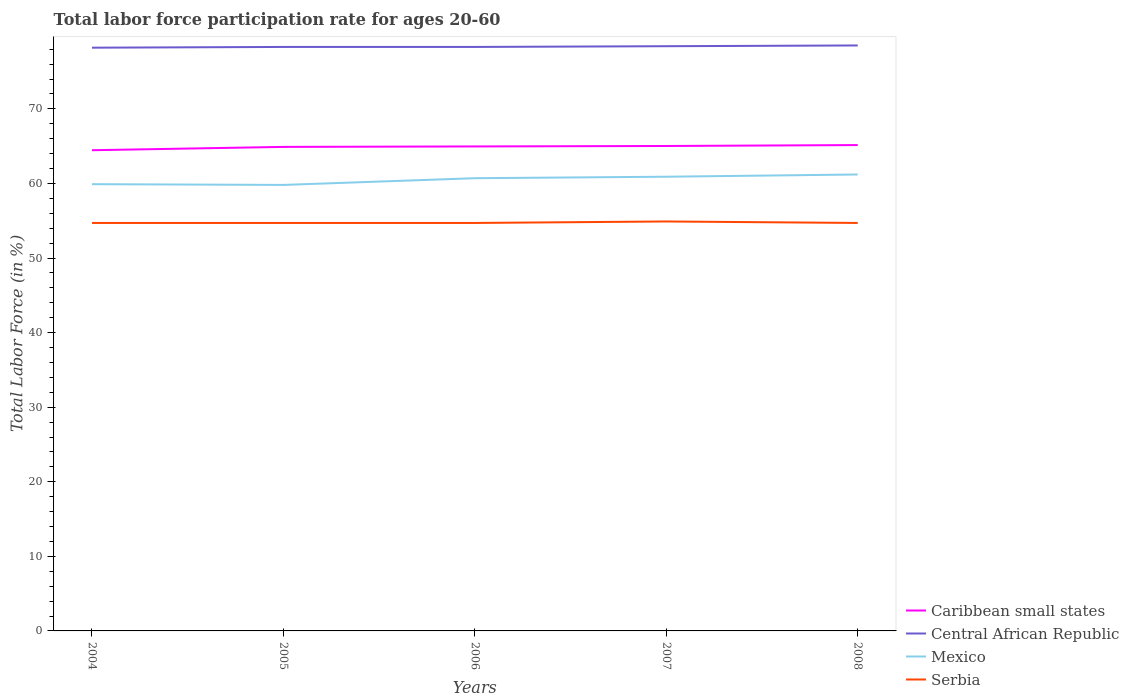Across all years, what is the maximum labor force participation rate in Caribbean small states?
Provide a short and direct response. 64.45. What is the total labor force participation rate in Mexico in the graph?
Your response must be concise. 0.1. What is the difference between the highest and the second highest labor force participation rate in Mexico?
Your response must be concise. 1.4. What is the difference between the highest and the lowest labor force participation rate in Caribbean small states?
Offer a terse response. 4. How many years are there in the graph?
Offer a terse response. 5. What is the difference between two consecutive major ticks on the Y-axis?
Your answer should be compact. 10. Does the graph contain any zero values?
Keep it short and to the point. No. How many legend labels are there?
Offer a terse response. 4. What is the title of the graph?
Ensure brevity in your answer.  Total labor force participation rate for ages 20-60. What is the label or title of the X-axis?
Make the answer very short. Years. What is the Total Labor Force (in %) in Caribbean small states in 2004?
Give a very brief answer. 64.45. What is the Total Labor Force (in %) of Central African Republic in 2004?
Make the answer very short. 78.2. What is the Total Labor Force (in %) in Mexico in 2004?
Provide a succinct answer. 59.9. What is the Total Labor Force (in %) of Serbia in 2004?
Your answer should be compact. 54.7. What is the Total Labor Force (in %) in Caribbean small states in 2005?
Provide a short and direct response. 64.9. What is the Total Labor Force (in %) in Central African Republic in 2005?
Make the answer very short. 78.3. What is the Total Labor Force (in %) of Mexico in 2005?
Offer a very short reply. 59.8. What is the Total Labor Force (in %) of Serbia in 2005?
Offer a terse response. 54.7. What is the Total Labor Force (in %) of Caribbean small states in 2006?
Your answer should be compact. 64.96. What is the Total Labor Force (in %) of Central African Republic in 2006?
Keep it short and to the point. 78.3. What is the Total Labor Force (in %) of Mexico in 2006?
Ensure brevity in your answer.  60.7. What is the Total Labor Force (in %) of Serbia in 2006?
Your answer should be very brief. 54.7. What is the Total Labor Force (in %) of Caribbean small states in 2007?
Keep it short and to the point. 65.02. What is the Total Labor Force (in %) in Central African Republic in 2007?
Offer a terse response. 78.4. What is the Total Labor Force (in %) of Mexico in 2007?
Keep it short and to the point. 60.9. What is the Total Labor Force (in %) in Serbia in 2007?
Offer a terse response. 54.9. What is the Total Labor Force (in %) of Caribbean small states in 2008?
Provide a succinct answer. 65.14. What is the Total Labor Force (in %) in Central African Republic in 2008?
Provide a succinct answer. 78.5. What is the Total Labor Force (in %) of Mexico in 2008?
Make the answer very short. 61.2. What is the Total Labor Force (in %) in Serbia in 2008?
Make the answer very short. 54.7. Across all years, what is the maximum Total Labor Force (in %) of Caribbean small states?
Give a very brief answer. 65.14. Across all years, what is the maximum Total Labor Force (in %) of Central African Republic?
Give a very brief answer. 78.5. Across all years, what is the maximum Total Labor Force (in %) in Mexico?
Provide a succinct answer. 61.2. Across all years, what is the maximum Total Labor Force (in %) of Serbia?
Make the answer very short. 54.9. Across all years, what is the minimum Total Labor Force (in %) of Caribbean small states?
Your answer should be very brief. 64.45. Across all years, what is the minimum Total Labor Force (in %) of Central African Republic?
Make the answer very short. 78.2. Across all years, what is the minimum Total Labor Force (in %) in Mexico?
Your answer should be very brief. 59.8. Across all years, what is the minimum Total Labor Force (in %) in Serbia?
Offer a very short reply. 54.7. What is the total Total Labor Force (in %) of Caribbean small states in the graph?
Your answer should be compact. 324.48. What is the total Total Labor Force (in %) of Central African Republic in the graph?
Your response must be concise. 391.7. What is the total Total Labor Force (in %) of Mexico in the graph?
Your response must be concise. 302.5. What is the total Total Labor Force (in %) in Serbia in the graph?
Provide a succinct answer. 273.7. What is the difference between the Total Labor Force (in %) of Caribbean small states in 2004 and that in 2005?
Ensure brevity in your answer.  -0.45. What is the difference between the Total Labor Force (in %) in Central African Republic in 2004 and that in 2005?
Your answer should be very brief. -0.1. What is the difference between the Total Labor Force (in %) of Mexico in 2004 and that in 2005?
Your response must be concise. 0.1. What is the difference between the Total Labor Force (in %) of Serbia in 2004 and that in 2005?
Ensure brevity in your answer.  0. What is the difference between the Total Labor Force (in %) in Caribbean small states in 2004 and that in 2006?
Offer a terse response. -0.51. What is the difference between the Total Labor Force (in %) of Serbia in 2004 and that in 2006?
Your answer should be compact. 0. What is the difference between the Total Labor Force (in %) of Caribbean small states in 2004 and that in 2007?
Your response must be concise. -0.57. What is the difference between the Total Labor Force (in %) of Caribbean small states in 2004 and that in 2008?
Provide a succinct answer. -0.69. What is the difference between the Total Labor Force (in %) in Central African Republic in 2004 and that in 2008?
Provide a succinct answer. -0.3. What is the difference between the Total Labor Force (in %) in Caribbean small states in 2005 and that in 2006?
Your answer should be very brief. -0.06. What is the difference between the Total Labor Force (in %) of Mexico in 2005 and that in 2006?
Offer a terse response. -0.9. What is the difference between the Total Labor Force (in %) of Serbia in 2005 and that in 2006?
Your response must be concise. 0. What is the difference between the Total Labor Force (in %) in Caribbean small states in 2005 and that in 2007?
Keep it short and to the point. -0.12. What is the difference between the Total Labor Force (in %) of Caribbean small states in 2005 and that in 2008?
Offer a terse response. -0.25. What is the difference between the Total Labor Force (in %) of Mexico in 2005 and that in 2008?
Provide a short and direct response. -1.4. What is the difference between the Total Labor Force (in %) in Caribbean small states in 2006 and that in 2007?
Your response must be concise. -0.06. What is the difference between the Total Labor Force (in %) in Caribbean small states in 2006 and that in 2008?
Ensure brevity in your answer.  -0.18. What is the difference between the Total Labor Force (in %) in Central African Republic in 2006 and that in 2008?
Make the answer very short. -0.2. What is the difference between the Total Labor Force (in %) in Caribbean small states in 2007 and that in 2008?
Your response must be concise. -0.12. What is the difference between the Total Labor Force (in %) in Central African Republic in 2007 and that in 2008?
Your response must be concise. -0.1. What is the difference between the Total Labor Force (in %) of Mexico in 2007 and that in 2008?
Make the answer very short. -0.3. What is the difference between the Total Labor Force (in %) of Caribbean small states in 2004 and the Total Labor Force (in %) of Central African Republic in 2005?
Offer a very short reply. -13.85. What is the difference between the Total Labor Force (in %) of Caribbean small states in 2004 and the Total Labor Force (in %) of Mexico in 2005?
Your answer should be compact. 4.65. What is the difference between the Total Labor Force (in %) of Caribbean small states in 2004 and the Total Labor Force (in %) of Serbia in 2005?
Offer a terse response. 9.75. What is the difference between the Total Labor Force (in %) of Central African Republic in 2004 and the Total Labor Force (in %) of Mexico in 2005?
Your response must be concise. 18.4. What is the difference between the Total Labor Force (in %) of Central African Republic in 2004 and the Total Labor Force (in %) of Serbia in 2005?
Your answer should be compact. 23.5. What is the difference between the Total Labor Force (in %) of Caribbean small states in 2004 and the Total Labor Force (in %) of Central African Republic in 2006?
Ensure brevity in your answer.  -13.85. What is the difference between the Total Labor Force (in %) in Caribbean small states in 2004 and the Total Labor Force (in %) in Mexico in 2006?
Give a very brief answer. 3.75. What is the difference between the Total Labor Force (in %) in Caribbean small states in 2004 and the Total Labor Force (in %) in Serbia in 2006?
Your response must be concise. 9.75. What is the difference between the Total Labor Force (in %) of Central African Republic in 2004 and the Total Labor Force (in %) of Mexico in 2006?
Give a very brief answer. 17.5. What is the difference between the Total Labor Force (in %) of Mexico in 2004 and the Total Labor Force (in %) of Serbia in 2006?
Give a very brief answer. 5.2. What is the difference between the Total Labor Force (in %) in Caribbean small states in 2004 and the Total Labor Force (in %) in Central African Republic in 2007?
Give a very brief answer. -13.95. What is the difference between the Total Labor Force (in %) of Caribbean small states in 2004 and the Total Labor Force (in %) of Mexico in 2007?
Give a very brief answer. 3.55. What is the difference between the Total Labor Force (in %) in Caribbean small states in 2004 and the Total Labor Force (in %) in Serbia in 2007?
Offer a terse response. 9.55. What is the difference between the Total Labor Force (in %) in Central African Republic in 2004 and the Total Labor Force (in %) in Serbia in 2007?
Your response must be concise. 23.3. What is the difference between the Total Labor Force (in %) in Mexico in 2004 and the Total Labor Force (in %) in Serbia in 2007?
Offer a terse response. 5. What is the difference between the Total Labor Force (in %) in Caribbean small states in 2004 and the Total Labor Force (in %) in Central African Republic in 2008?
Your answer should be very brief. -14.05. What is the difference between the Total Labor Force (in %) in Caribbean small states in 2004 and the Total Labor Force (in %) in Mexico in 2008?
Make the answer very short. 3.25. What is the difference between the Total Labor Force (in %) in Caribbean small states in 2004 and the Total Labor Force (in %) in Serbia in 2008?
Your answer should be very brief. 9.75. What is the difference between the Total Labor Force (in %) of Caribbean small states in 2005 and the Total Labor Force (in %) of Central African Republic in 2006?
Your response must be concise. -13.4. What is the difference between the Total Labor Force (in %) in Caribbean small states in 2005 and the Total Labor Force (in %) in Mexico in 2006?
Provide a short and direct response. 4.2. What is the difference between the Total Labor Force (in %) of Caribbean small states in 2005 and the Total Labor Force (in %) of Serbia in 2006?
Provide a succinct answer. 10.2. What is the difference between the Total Labor Force (in %) of Central African Republic in 2005 and the Total Labor Force (in %) of Serbia in 2006?
Provide a succinct answer. 23.6. What is the difference between the Total Labor Force (in %) of Caribbean small states in 2005 and the Total Labor Force (in %) of Central African Republic in 2007?
Make the answer very short. -13.5. What is the difference between the Total Labor Force (in %) in Caribbean small states in 2005 and the Total Labor Force (in %) in Mexico in 2007?
Make the answer very short. 4. What is the difference between the Total Labor Force (in %) in Caribbean small states in 2005 and the Total Labor Force (in %) in Serbia in 2007?
Your answer should be compact. 10. What is the difference between the Total Labor Force (in %) in Central African Republic in 2005 and the Total Labor Force (in %) in Mexico in 2007?
Offer a very short reply. 17.4. What is the difference between the Total Labor Force (in %) in Central African Republic in 2005 and the Total Labor Force (in %) in Serbia in 2007?
Keep it short and to the point. 23.4. What is the difference between the Total Labor Force (in %) in Caribbean small states in 2005 and the Total Labor Force (in %) in Central African Republic in 2008?
Provide a short and direct response. -13.6. What is the difference between the Total Labor Force (in %) in Caribbean small states in 2005 and the Total Labor Force (in %) in Mexico in 2008?
Make the answer very short. 3.7. What is the difference between the Total Labor Force (in %) of Caribbean small states in 2005 and the Total Labor Force (in %) of Serbia in 2008?
Provide a succinct answer. 10.2. What is the difference between the Total Labor Force (in %) of Central African Republic in 2005 and the Total Labor Force (in %) of Serbia in 2008?
Ensure brevity in your answer.  23.6. What is the difference between the Total Labor Force (in %) of Caribbean small states in 2006 and the Total Labor Force (in %) of Central African Republic in 2007?
Your answer should be compact. -13.44. What is the difference between the Total Labor Force (in %) in Caribbean small states in 2006 and the Total Labor Force (in %) in Mexico in 2007?
Provide a succinct answer. 4.06. What is the difference between the Total Labor Force (in %) of Caribbean small states in 2006 and the Total Labor Force (in %) of Serbia in 2007?
Your response must be concise. 10.06. What is the difference between the Total Labor Force (in %) in Central African Republic in 2006 and the Total Labor Force (in %) in Mexico in 2007?
Offer a very short reply. 17.4. What is the difference between the Total Labor Force (in %) in Central African Republic in 2006 and the Total Labor Force (in %) in Serbia in 2007?
Give a very brief answer. 23.4. What is the difference between the Total Labor Force (in %) in Caribbean small states in 2006 and the Total Labor Force (in %) in Central African Republic in 2008?
Provide a short and direct response. -13.54. What is the difference between the Total Labor Force (in %) of Caribbean small states in 2006 and the Total Labor Force (in %) of Mexico in 2008?
Your response must be concise. 3.76. What is the difference between the Total Labor Force (in %) of Caribbean small states in 2006 and the Total Labor Force (in %) of Serbia in 2008?
Your response must be concise. 10.26. What is the difference between the Total Labor Force (in %) in Central African Republic in 2006 and the Total Labor Force (in %) in Mexico in 2008?
Keep it short and to the point. 17.1. What is the difference between the Total Labor Force (in %) in Central African Republic in 2006 and the Total Labor Force (in %) in Serbia in 2008?
Your answer should be compact. 23.6. What is the difference between the Total Labor Force (in %) of Caribbean small states in 2007 and the Total Labor Force (in %) of Central African Republic in 2008?
Your answer should be very brief. -13.48. What is the difference between the Total Labor Force (in %) of Caribbean small states in 2007 and the Total Labor Force (in %) of Mexico in 2008?
Give a very brief answer. 3.82. What is the difference between the Total Labor Force (in %) in Caribbean small states in 2007 and the Total Labor Force (in %) in Serbia in 2008?
Ensure brevity in your answer.  10.32. What is the difference between the Total Labor Force (in %) in Central African Republic in 2007 and the Total Labor Force (in %) in Serbia in 2008?
Give a very brief answer. 23.7. What is the difference between the Total Labor Force (in %) in Mexico in 2007 and the Total Labor Force (in %) in Serbia in 2008?
Provide a succinct answer. 6.2. What is the average Total Labor Force (in %) in Caribbean small states per year?
Offer a terse response. 64.89. What is the average Total Labor Force (in %) of Central African Republic per year?
Keep it short and to the point. 78.34. What is the average Total Labor Force (in %) in Mexico per year?
Make the answer very short. 60.5. What is the average Total Labor Force (in %) of Serbia per year?
Provide a short and direct response. 54.74. In the year 2004, what is the difference between the Total Labor Force (in %) of Caribbean small states and Total Labor Force (in %) of Central African Republic?
Your answer should be very brief. -13.75. In the year 2004, what is the difference between the Total Labor Force (in %) in Caribbean small states and Total Labor Force (in %) in Mexico?
Your response must be concise. 4.55. In the year 2004, what is the difference between the Total Labor Force (in %) in Caribbean small states and Total Labor Force (in %) in Serbia?
Make the answer very short. 9.75. In the year 2004, what is the difference between the Total Labor Force (in %) in Mexico and Total Labor Force (in %) in Serbia?
Your answer should be compact. 5.2. In the year 2005, what is the difference between the Total Labor Force (in %) in Caribbean small states and Total Labor Force (in %) in Central African Republic?
Your answer should be compact. -13.4. In the year 2005, what is the difference between the Total Labor Force (in %) of Caribbean small states and Total Labor Force (in %) of Mexico?
Offer a terse response. 5.1. In the year 2005, what is the difference between the Total Labor Force (in %) of Caribbean small states and Total Labor Force (in %) of Serbia?
Offer a terse response. 10.2. In the year 2005, what is the difference between the Total Labor Force (in %) of Central African Republic and Total Labor Force (in %) of Serbia?
Make the answer very short. 23.6. In the year 2005, what is the difference between the Total Labor Force (in %) of Mexico and Total Labor Force (in %) of Serbia?
Provide a succinct answer. 5.1. In the year 2006, what is the difference between the Total Labor Force (in %) of Caribbean small states and Total Labor Force (in %) of Central African Republic?
Make the answer very short. -13.34. In the year 2006, what is the difference between the Total Labor Force (in %) in Caribbean small states and Total Labor Force (in %) in Mexico?
Your answer should be compact. 4.26. In the year 2006, what is the difference between the Total Labor Force (in %) of Caribbean small states and Total Labor Force (in %) of Serbia?
Your response must be concise. 10.26. In the year 2006, what is the difference between the Total Labor Force (in %) in Central African Republic and Total Labor Force (in %) in Mexico?
Your response must be concise. 17.6. In the year 2006, what is the difference between the Total Labor Force (in %) in Central African Republic and Total Labor Force (in %) in Serbia?
Your response must be concise. 23.6. In the year 2006, what is the difference between the Total Labor Force (in %) in Mexico and Total Labor Force (in %) in Serbia?
Keep it short and to the point. 6. In the year 2007, what is the difference between the Total Labor Force (in %) of Caribbean small states and Total Labor Force (in %) of Central African Republic?
Your response must be concise. -13.38. In the year 2007, what is the difference between the Total Labor Force (in %) of Caribbean small states and Total Labor Force (in %) of Mexico?
Your answer should be very brief. 4.12. In the year 2007, what is the difference between the Total Labor Force (in %) of Caribbean small states and Total Labor Force (in %) of Serbia?
Ensure brevity in your answer.  10.12. In the year 2007, what is the difference between the Total Labor Force (in %) of Central African Republic and Total Labor Force (in %) of Serbia?
Ensure brevity in your answer.  23.5. In the year 2008, what is the difference between the Total Labor Force (in %) of Caribbean small states and Total Labor Force (in %) of Central African Republic?
Offer a terse response. -13.36. In the year 2008, what is the difference between the Total Labor Force (in %) of Caribbean small states and Total Labor Force (in %) of Mexico?
Make the answer very short. 3.94. In the year 2008, what is the difference between the Total Labor Force (in %) in Caribbean small states and Total Labor Force (in %) in Serbia?
Your answer should be very brief. 10.44. In the year 2008, what is the difference between the Total Labor Force (in %) of Central African Republic and Total Labor Force (in %) of Mexico?
Offer a terse response. 17.3. In the year 2008, what is the difference between the Total Labor Force (in %) in Central African Republic and Total Labor Force (in %) in Serbia?
Your response must be concise. 23.8. What is the ratio of the Total Labor Force (in %) in Serbia in 2004 to that in 2006?
Make the answer very short. 1. What is the ratio of the Total Labor Force (in %) in Central African Republic in 2004 to that in 2007?
Offer a very short reply. 1. What is the ratio of the Total Labor Force (in %) of Mexico in 2004 to that in 2007?
Give a very brief answer. 0.98. What is the ratio of the Total Labor Force (in %) of Serbia in 2004 to that in 2007?
Your response must be concise. 1. What is the ratio of the Total Labor Force (in %) in Caribbean small states in 2004 to that in 2008?
Make the answer very short. 0.99. What is the ratio of the Total Labor Force (in %) in Central African Republic in 2004 to that in 2008?
Provide a short and direct response. 1. What is the ratio of the Total Labor Force (in %) of Mexico in 2004 to that in 2008?
Provide a succinct answer. 0.98. What is the ratio of the Total Labor Force (in %) in Caribbean small states in 2005 to that in 2006?
Give a very brief answer. 1. What is the ratio of the Total Labor Force (in %) of Central African Republic in 2005 to that in 2006?
Offer a very short reply. 1. What is the ratio of the Total Labor Force (in %) of Mexico in 2005 to that in 2006?
Give a very brief answer. 0.99. What is the ratio of the Total Labor Force (in %) in Serbia in 2005 to that in 2006?
Ensure brevity in your answer.  1. What is the ratio of the Total Labor Force (in %) in Central African Republic in 2005 to that in 2007?
Keep it short and to the point. 1. What is the ratio of the Total Labor Force (in %) of Mexico in 2005 to that in 2007?
Provide a succinct answer. 0.98. What is the ratio of the Total Labor Force (in %) of Caribbean small states in 2005 to that in 2008?
Your answer should be very brief. 1. What is the ratio of the Total Labor Force (in %) of Mexico in 2005 to that in 2008?
Your answer should be compact. 0.98. What is the ratio of the Total Labor Force (in %) in Caribbean small states in 2006 to that in 2007?
Your answer should be compact. 1. What is the ratio of the Total Labor Force (in %) in Serbia in 2006 to that in 2007?
Offer a very short reply. 1. What is the ratio of the Total Labor Force (in %) of Serbia in 2006 to that in 2008?
Your response must be concise. 1. What is the ratio of the Total Labor Force (in %) of Central African Republic in 2007 to that in 2008?
Your answer should be very brief. 1. What is the difference between the highest and the second highest Total Labor Force (in %) in Caribbean small states?
Provide a short and direct response. 0.12. What is the difference between the highest and the second highest Total Labor Force (in %) in Central African Republic?
Make the answer very short. 0.1. What is the difference between the highest and the second highest Total Labor Force (in %) in Mexico?
Make the answer very short. 0.3. What is the difference between the highest and the lowest Total Labor Force (in %) in Caribbean small states?
Ensure brevity in your answer.  0.69. What is the difference between the highest and the lowest Total Labor Force (in %) of Central African Republic?
Provide a succinct answer. 0.3. What is the difference between the highest and the lowest Total Labor Force (in %) in Mexico?
Offer a terse response. 1.4. What is the difference between the highest and the lowest Total Labor Force (in %) of Serbia?
Keep it short and to the point. 0.2. 